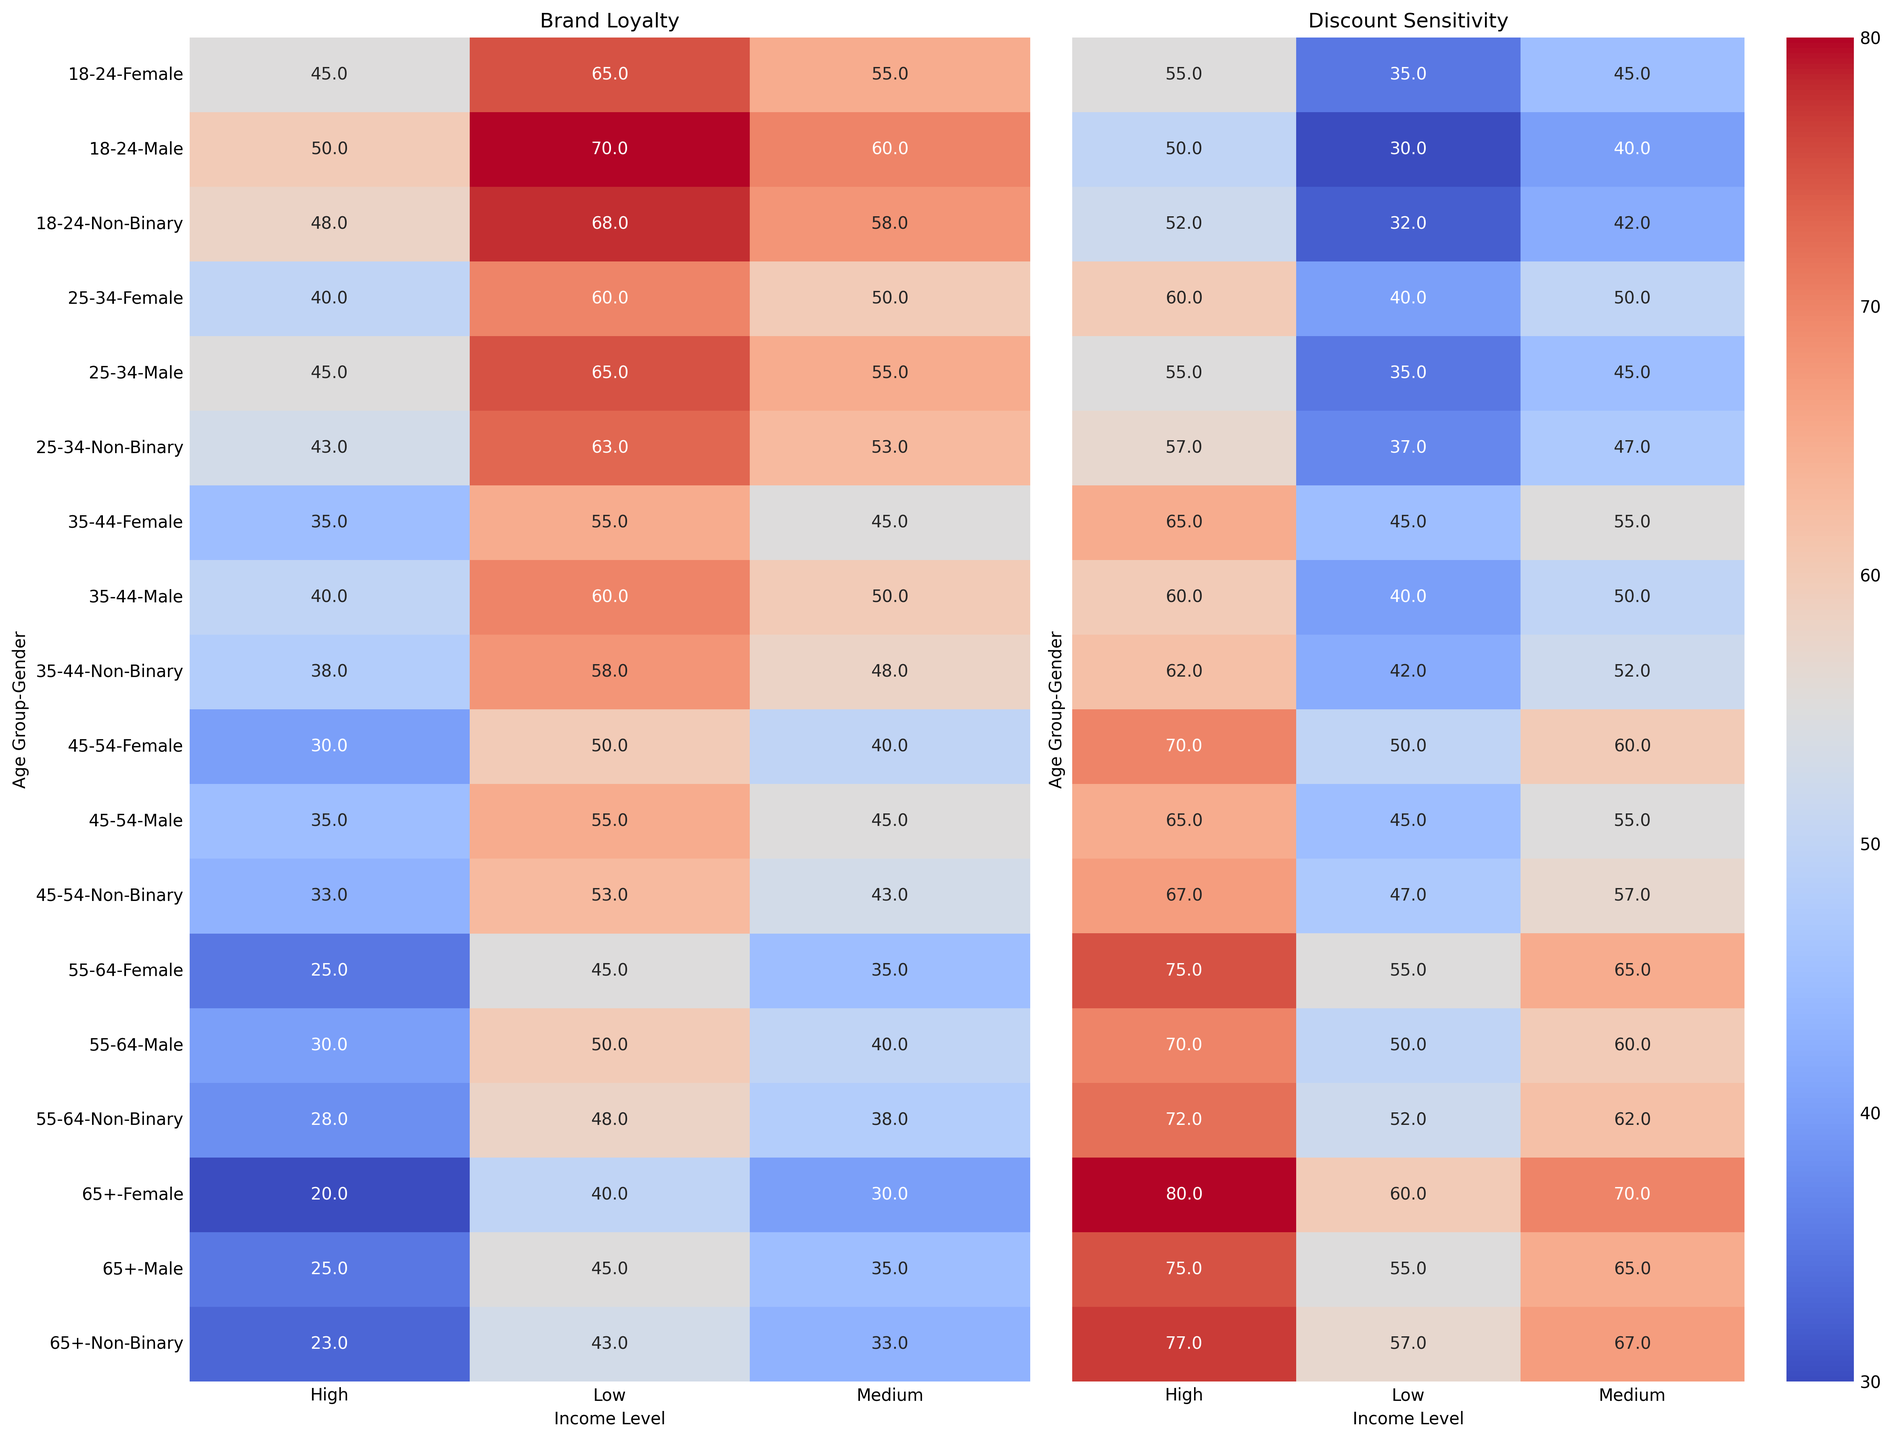Which age group and income level has the lowest brand loyalty across all genders? Look at the Brand Loyalty heatmap and identify the smallest value across all age groups, income levels, and genders. For "65+" with "High" income, Non-Binary shows the lowest brand loyalty at 23.
Answer: 65+, High, Non-Binary In which demographic is discount sensitivity the highest? Refer to the Discount Sensitivity heatmap and find the cell with the highest value. The cell with the highest Discount Sensitivity is 80, found in the "65+" age group, "High" income level, Female gender.
Answer: 65+, High, Female Are males in the 18-24 age group more brand loyal at lower or higher income levels? Compare the Brand Loyalty values for 18-24 males across low, medium, and high income levels in the Brand Loyalty heatmap. "Low" income shows 70, "Medium" shows 60, and "High" shows 50.
Answer: Lower income levels What is the difference in discount sensitivity between 25-34-year-old females with medium income and those with high income? Check the Discount Sensitivity values for 25-34 females in the medium and high income levels. Discount sensitivity for medium is 50, and for high is 60. The difference is 60 - 50 = 10.
Answer: 10 Who shows more brand loyalty: 35-44-year-old males with medium income or 55-64-year-old males with low income? Look at the Brand Loyalty heatmap: 35-44 males with medium income have a value of 50, and 55-64 males with low income have a value of 50. Both are the same.
Answer: Equal For the 45-54 age group, how does brand loyalty change across income levels for females? Observe the Brand Loyalty values for 45-54 females across low, medium, and high income levels. For low income, it is 50, medium is 40, and high is 30. The values demonstrate a decreasing trend.
Answer: Decreases Which gender has the least brand loyalty in the 18-24 age group across all income levels? Identify the Brand Loyalty values for all genders in the 18-24 age group. Non-Binary values are 68, 58, and 48 for low, medium, and high income, showing consistently lower values among genders.
Answer: Non-Binary What is the average discount sensitivity for the 65+ age group with medium income? Look at the Discount Sensitivity values for the 65+ age group with medium income across all genders: 65, 70, and 67. Calculate the average: (65 + 70 + 67)/3 = 67.33.
Answer: 67.33 